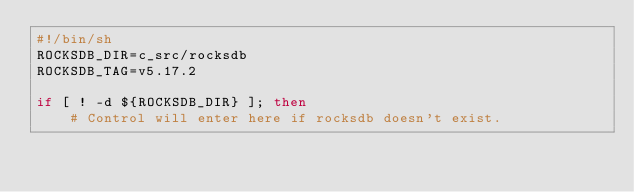Convert code to text. <code><loc_0><loc_0><loc_500><loc_500><_Bash_>#!/bin/sh
ROCKSDB_DIR=c_src/rocksdb
ROCKSDB_TAG=v5.17.2

if [ ! -d ${ROCKSDB_DIR} ]; then
    # Control will enter here if rocksdb doesn't exist.</code> 